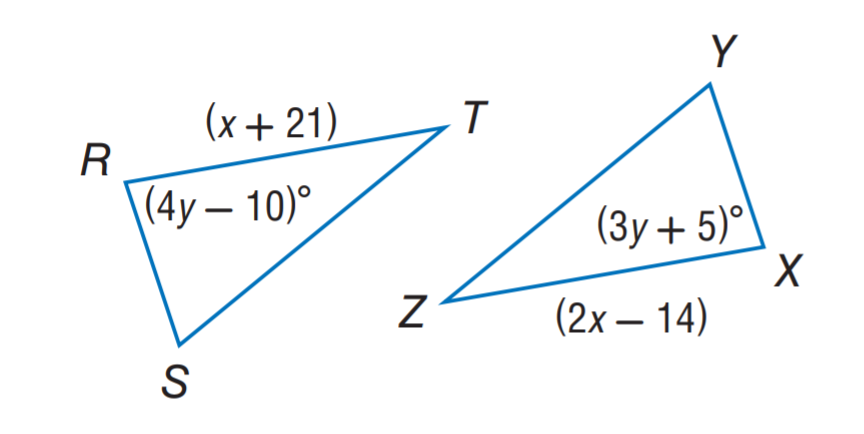Answer the mathemtical geometry problem and directly provide the correct option letter.
Question: \triangle R S T \cong \triangle X Y Z. Find x.
Choices: A: 10 B: 15 C: 21 D: 35 D 